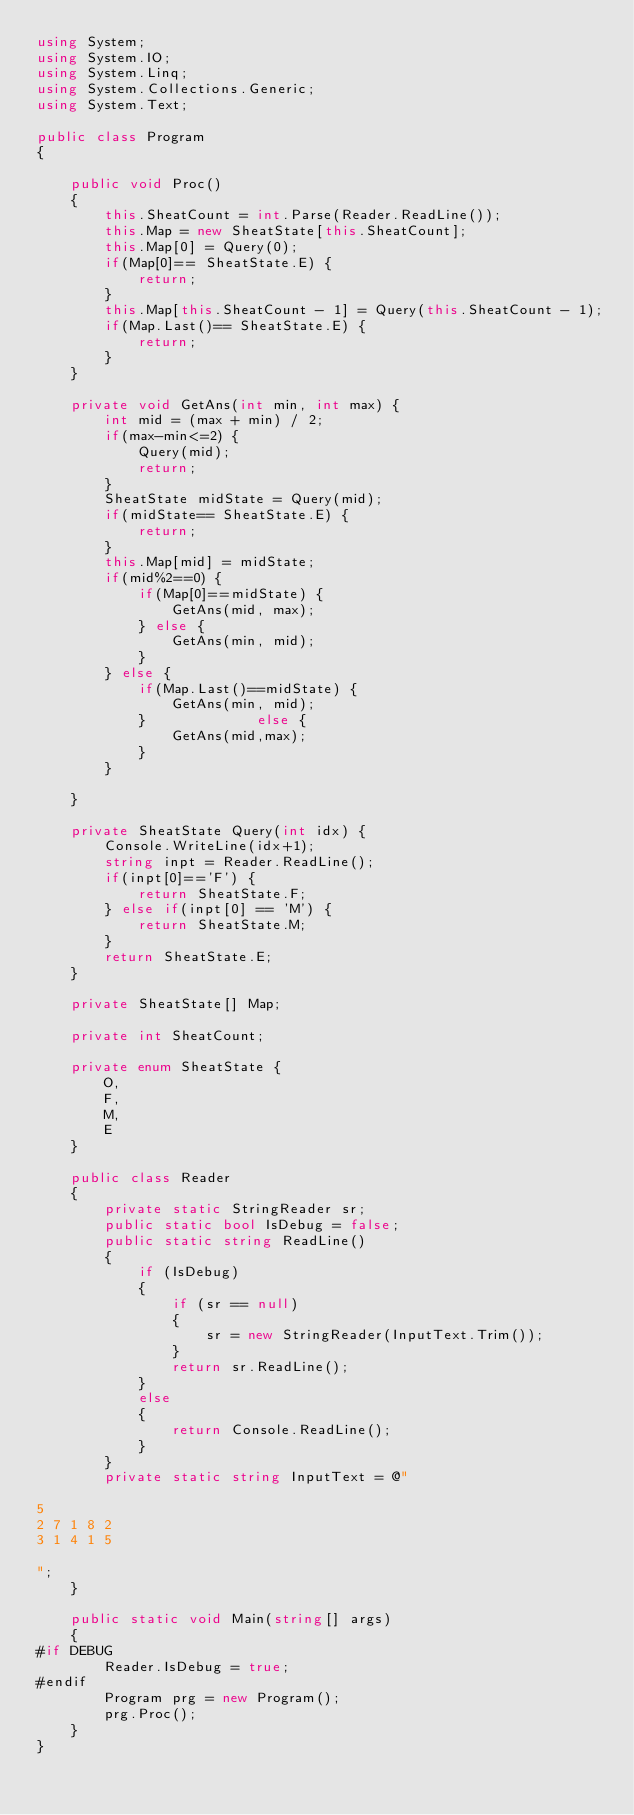<code> <loc_0><loc_0><loc_500><loc_500><_C#_>using System;
using System.IO;
using System.Linq;
using System.Collections.Generic;
using System.Text;

public class Program
{

    public void Proc()
    {
        this.SheatCount = int.Parse(Reader.ReadLine());
        this.Map = new SheatState[this.SheatCount];
        this.Map[0] = Query(0);
        if(Map[0]== SheatState.E) {
            return;
        }
        this.Map[this.SheatCount - 1] = Query(this.SheatCount - 1);
        if(Map.Last()== SheatState.E) {
            return;
        }
    }

    private void GetAns(int min, int max) {
        int mid = (max + min) / 2;
        if(max-min<=2) {
            Query(mid);
            return;
        }
        SheatState midState = Query(mid);
        if(midState== SheatState.E) {
            return;
        }
        this.Map[mid] = midState;
        if(mid%2==0) {
            if(Map[0]==midState) {
                GetAns(mid, max);
            } else {
                GetAns(min, mid);
            }
        } else {
            if(Map.Last()==midState) {
                GetAns(min, mid);
            }             else {
                GetAns(mid,max);
            }
        }

    }

    private SheatState Query(int idx) {
        Console.WriteLine(idx+1);
        string inpt = Reader.ReadLine();
        if(inpt[0]=='F') {
            return SheatState.F;
        } else if(inpt[0] == 'M') {
            return SheatState.M;
        }
        return SheatState.E;
    }

    private SheatState[] Map;

    private int SheatCount;

    private enum SheatState {
        O,
        F,
        M,
        E
    }

    public class Reader
    {
        private static StringReader sr;
        public static bool IsDebug = false;
        public static string ReadLine()
        {
            if (IsDebug)
            {
                if (sr == null)
                {
                    sr = new StringReader(InputText.Trim());
                }
                return sr.ReadLine();
            }
            else
            {
                return Console.ReadLine();
            }
        }
        private static string InputText = @"

5
2 7 1 8 2
3 1 4 1 5

";
    }

    public static void Main(string[] args)
    {
#if DEBUG
        Reader.IsDebug = true;
#endif
        Program prg = new Program();
        prg.Proc();
    }
}
</code> 